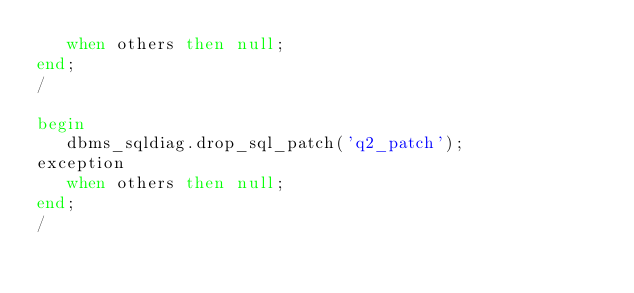Convert code to text. <code><loc_0><loc_0><loc_500><loc_500><_SQL_>   when others then null;
end;
/

begin
   dbms_sqldiag.drop_sql_patch('q2_patch');
exception
   when others then null;
end;
/

</code> 